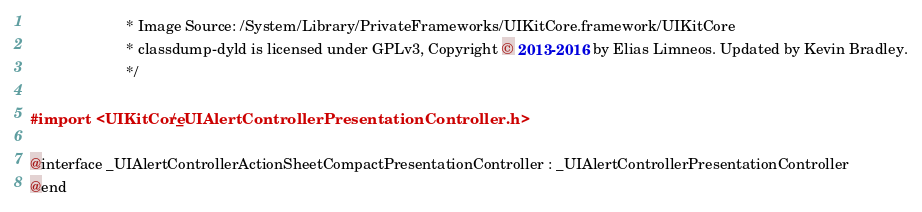<code> <loc_0><loc_0><loc_500><loc_500><_C_>                       * Image Source: /System/Library/PrivateFrameworks/UIKitCore.framework/UIKitCore
                       * classdump-dyld is licensed under GPLv3, Copyright © 2013-2016 by Elias Limneos. Updated by Kevin Bradley.
                       */

#import <UIKitCore/_UIAlertControllerPresentationController.h>

@interface _UIAlertControllerActionSheetCompactPresentationController : _UIAlertControllerPresentationController
@end

</code> 